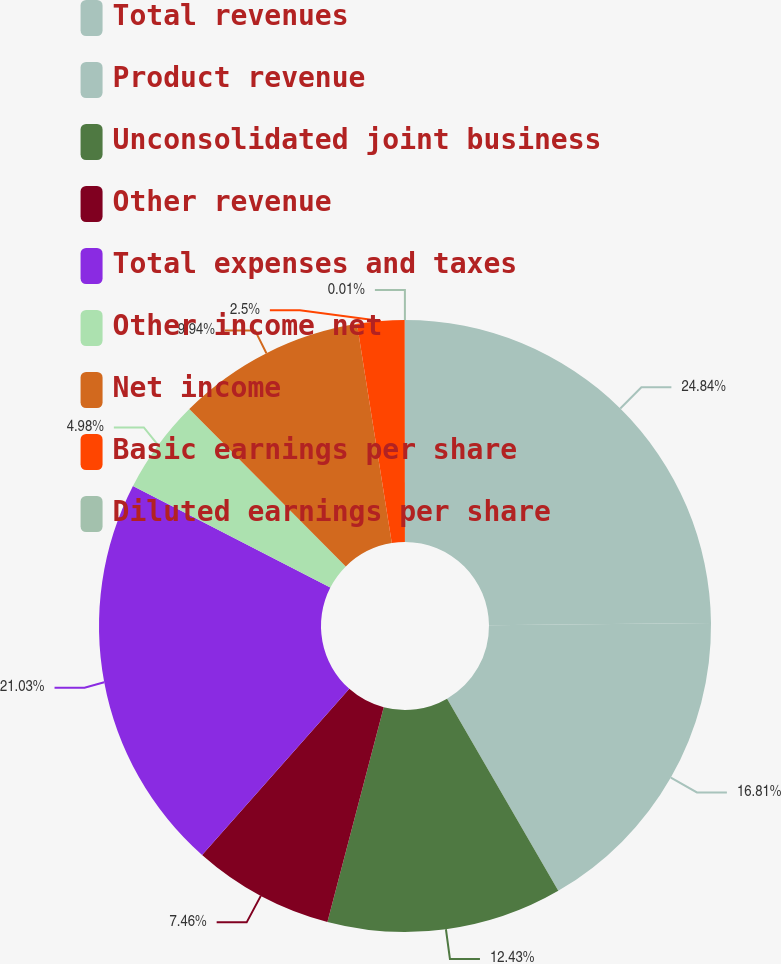Convert chart. <chart><loc_0><loc_0><loc_500><loc_500><pie_chart><fcel>Total revenues<fcel>Product revenue<fcel>Unconsolidated joint business<fcel>Other revenue<fcel>Total expenses and taxes<fcel>Other income net<fcel>Net income<fcel>Basic earnings per share<fcel>Diluted earnings per share<nl><fcel>24.84%<fcel>16.81%<fcel>12.43%<fcel>7.46%<fcel>21.03%<fcel>4.98%<fcel>9.94%<fcel>2.5%<fcel>0.01%<nl></chart> 